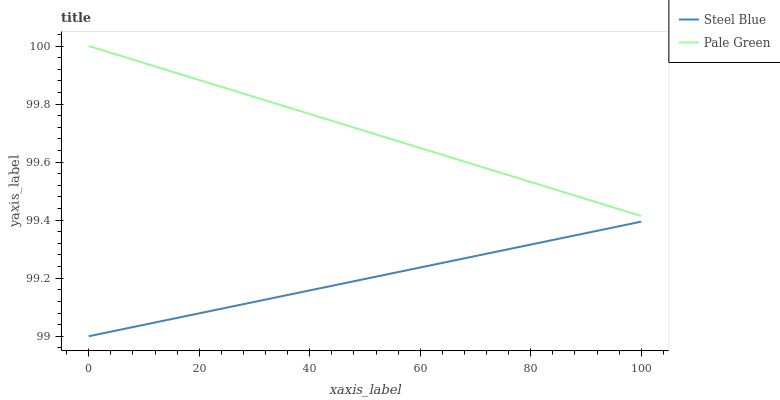Does Steel Blue have the minimum area under the curve?
Answer yes or no. Yes. Does Pale Green have the maximum area under the curve?
Answer yes or no. Yes. Does Steel Blue have the maximum area under the curve?
Answer yes or no. No. Is Pale Green the smoothest?
Answer yes or no. Yes. Is Steel Blue the roughest?
Answer yes or no. Yes. Is Steel Blue the smoothest?
Answer yes or no. No. Does Steel Blue have the lowest value?
Answer yes or no. Yes. Does Pale Green have the highest value?
Answer yes or no. Yes. Does Steel Blue have the highest value?
Answer yes or no. No. Is Steel Blue less than Pale Green?
Answer yes or no. Yes. Is Pale Green greater than Steel Blue?
Answer yes or no. Yes. Does Steel Blue intersect Pale Green?
Answer yes or no. No. 